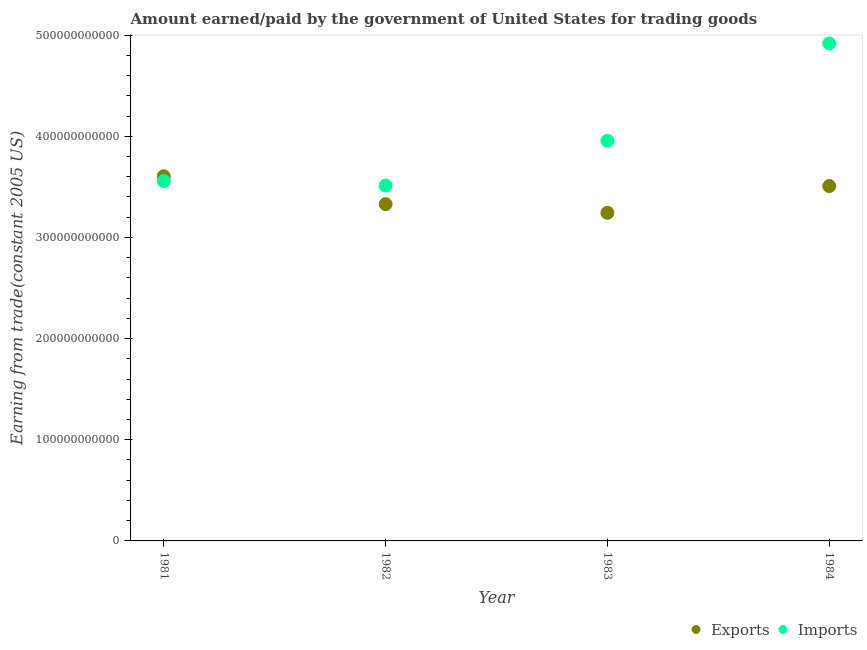How many different coloured dotlines are there?
Your response must be concise. 2. What is the amount paid for imports in 1981?
Your response must be concise. 3.56e+11. Across all years, what is the maximum amount earned from exports?
Offer a very short reply. 3.61e+11. Across all years, what is the minimum amount paid for imports?
Offer a terse response. 3.51e+11. In which year was the amount earned from exports maximum?
Your response must be concise. 1981. What is the total amount earned from exports in the graph?
Your answer should be very brief. 1.37e+12. What is the difference between the amount paid for imports in 1981 and that in 1984?
Your answer should be compact. -1.36e+11. What is the difference between the amount earned from exports in 1983 and the amount paid for imports in 1984?
Your response must be concise. -1.68e+11. What is the average amount paid for imports per year?
Offer a terse response. 3.99e+11. In the year 1984, what is the difference between the amount paid for imports and amount earned from exports?
Offer a very short reply. 1.41e+11. What is the ratio of the amount earned from exports in 1981 to that in 1984?
Give a very brief answer. 1.03. What is the difference between the highest and the second highest amount paid for imports?
Give a very brief answer. 9.63e+1. What is the difference between the highest and the lowest amount earned from exports?
Your response must be concise. 3.61e+1. Does the amount paid for imports monotonically increase over the years?
Keep it short and to the point. No. What is the difference between two consecutive major ticks on the Y-axis?
Ensure brevity in your answer.  1.00e+11. Does the graph contain any zero values?
Your answer should be very brief. No. Does the graph contain grids?
Your answer should be very brief. No. Where does the legend appear in the graph?
Provide a succinct answer. Bottom right. What is the title of the graph?
Give a very brief answer. Amount earned/paid by the government of United States for trading goods. What is the label or title of the X-axis?
Give a very brief answer. Year. What is the label or title of the Y-axis?
Make the answer very short. Earning from trade(constant 2005 US). What is the Earning from trade(constant 2005 US) in Exports in 1981?
Provide a short and direct response. 3.61e+11. What is the Earning from trade(constant 2005 US) in Imports in 1981?
Your answer should be very brief. 3.56e+11. What is the Earning from trade(constant 2005 US) of Exports in 1982?
Your answer should be compact. 3.33e+11. What is the Earning from trade(constant 2005 US) of Imports in 1982?
Your response must be concise. 3.51e+11. What is the Earning from trade(constant 2005 US) in Exports in 1983?
Provide a short and direct response. 3.24e+11. What is the Earning from trade(constant 2005 US) of Imports in 1983?
Offer a very short reply. 3.96e+11. What is the Earning from trade(constant 2005 US) in Exports in 1984?
Ensure brevity in your answer.  3.51e+11. What is the Earning from trade(constant 2005 US) in Imports in 1984?
Make the answer very short. 4.92e+11. Across all years, what is the maximum Earning from trade(constant 2005 US) of Exports?
Your response must be concise. 3.61e+11. Across all years, what is the maximum Earning from trade(constant 2005 US) in Imports?
Your answer should be very brief. 4.92e+11. Across all years, what is the minimum Earning from trade(constant 2005 US) in Exports?
Give a very brief answer. 3.24e+11. Across all years, what is the minimum Earning from trade(constant 2005 US) in Imports?
Offer a terse response. 3.51e+11. What is the total Earning from trade(constant 2005 US) of Exports in the graph?
Your response must be concise. 1.37e+12. What is the total Earning from trade(constant 2005 US) in Imports in the graph?
Offer a terse response. 1.59e+12. What is the difference between the Earning from trade(constant 2005 US) of Exports in 1981 and that in 1982?
Your answer should be compact. 2.76e+1. What is the difference between the Earning from trade(constant 2005 US) of Imports in 1981 and that in 1982?
Make the answer very short. 4.48e+09. What is the difference between the Earning from trade(constant 2005 US) of Exports in 1981 and that in 1983?
Offer a very short reply. 3.61e+1. What is the difference between the Earning from trade(constant 2005 US) in Imports in 1981 and that in 1983?
Ensure brevity in your answer.  -3.98e+1. What is the difference between the Earning from trade(constant 2005 US) in Exports in 1981 and that in 1984?
Your answer should be very brief. 9.68e+09. What is the difference between the Earning from trade(constant 2005 US) in Imports in 1981 and that in 1984?
Give a very brief answer. -1.36e+11. What is the difference between the Earning from trade(constant 2005 US) of Exports in 1982 and that in 1983?
Offer a very short reply. 8.59e+09. What is the difference between the Earning from trade(constant 2005 US) in Imports in 1982 and that in 1983?
Keep it short and to the point. -4.43e+1. What is the difference between the Earning from trade(constant 2005 US) of Exports in 1982 and that in 1984?
Your answer should be very brief. -1.79e+1. What is the difference between the Earning from trade(constant 2005 US) in Imports in 1982 and that in 1984?
Your answer should be compact. -1.41e+11. What is the difference between the Earning from trade(constant 2005 US) of Exports in 1983 and that in 1984?
Offer a very short reply. -2.65e+1. What is the difference between the Earning from trade(constant 2005 US) of Imports in 1983 and that in 1984?
Provide a short and direct response. -9.63e+1. What is the difference between the Earning from trade(constant 2005 US) in Exports in 1981 and the Earning from trade(constant 2005 US) in Imports in 1982?
Provide a succinct answer. 9.24e+09. What is the difference between the Earning from trade(constant 2005 US) in Exports in 1981 and the Earning from trade(constant 2005 US) in Imports in 1983?
Provide a short and direct response. -3.51e+1. What is the difference between the Earning from trade(constant 2005 US) of Exports in 1981 and the Earning from trade(constant 2005 US) of Imports in 1984?
Your answer should be very brief. -1.31e+11. What is the difference between the Earning from trade(constant 2005 US) of Exports in 1982 and the Earning from trade(constant 2005 US) of Imports in 1983?
Offer a terse response. -6.26e+1. What is the difference between the Earning from trade(constant 2005 US) in Exports in 1982 and the Earning from trade(constant 2005 US) in Imports in 1984?
Provide a short and direct response. -1.59e+11. What is the difference between the Earning from trade(constant 2005 US) of Exports in 1983 and the Earning from trade(constant 2005 US) of Imports in 1984?
Make the answer very short. -1.68e+11. What is the average Earning from trade(constant 2005 US) in Exports per year?
Offer a very short reply. 3.42e+11. What is the average Earning from trade(constant 2005 US) in Imports per year?
Your response must be concise. 3.99e+11. In the year 1981, what is the difference between the Earning from trade(constant 2005 US) in Exports and Earning from trade(constant 2005 US) in Imports?
Make the answer very short. 4.76e+09. In the year 1982, what is the difference between the Earning from trade(constant 2005 US) of Exports and Earning from trade(constant 2005 US) of Imports?
Offer a terse response. -1.83e+1. In the year 1983, what is the difference between the Earning from trade(constant 2005 US) in Exports and Earning from trade(constant 2005 US) in Imports?
Your response must be concise. -7.12e+1. In the year 1984, what is the difference between the Earning from trade(constant 2005 US) of Exports and Earning from trade(constant 2005 US) of Imports?
Provide a short and direct response. -1.41e+11. What is the ratio of the Earning from trade(constant 2005 US) of Exports in 1981 to that in 1982?
Provide a short and direct response. 1.08. What is the ratio of the Earning from trade(constant 2005 US) of Imports in 1981 to that in 1982?
Make the answer very short. 1.01. What is the ratio of the Earning from trade(constant 2005 US) of Exports in 1981 to that in 1983?
Your response must be concise. 1.11. What is the ratio of the Earning from trade(constant 2005 US) in Imports in 1981 to that in 1983?
Your answer should be very brief. 0.9. What is the ratio of the Earning from trade(constant 2005 US) in Exports in 1981 to that in 1984?
Offer a very short reply. 1.03. What is the ratio of the Earning from trade(constant 2005 US) in Imports in 1981 to that in 1984?
Offer a very short reply. 0.72. What is the ratio of the Earning from trade(constant 2005 US) in Exports in 1982 to that in 1983?
Your answer should be compact. 1.03. What is the ratio of the Earning from trade(constant 2005 US) in Imports in 1982 to that in 1983?
Ensure brevity in your answer.  0.89. What is the ratio of the Earning from trade(constant 2005 US) of Exports in 1982 to that in 1984?
Make the answer very short. 0.95. What is the ratio of the Earning from trade(constant 2005 US) in Imports in 1982 to that in 1984?
Ensure brevity in your answer.  0.71. What is the ratio of the Earning from trade(constant 2005 US) in Exports in 1983 to that in 1984?
Provide a short and direct response. 0.92. What is the ratio of the Earning from trade(constant 2005 US) of Imports in 1983 to that in 1984?
Your answer should be very brief. 0.8. What is the difference between the highest and the second highest Earning from trade(constant 2005 US) in Exports?
Your answer should be very brief. 9.68e+09. What is the difference between the highest and the second highest Earning from trade(constant 2005 US) in Imports?
Offer a terse response. 9.63e+1. What is the difference between the highest and the lowest Earning from trade(constant 2005 US) of Exports?
Keep it short and to the point. 3.61e+1. What is the difference between the highest and the lowest Earning from trade(constant 2005 US) of Imports?
Your answer should be very brief. 1.41e+11. 